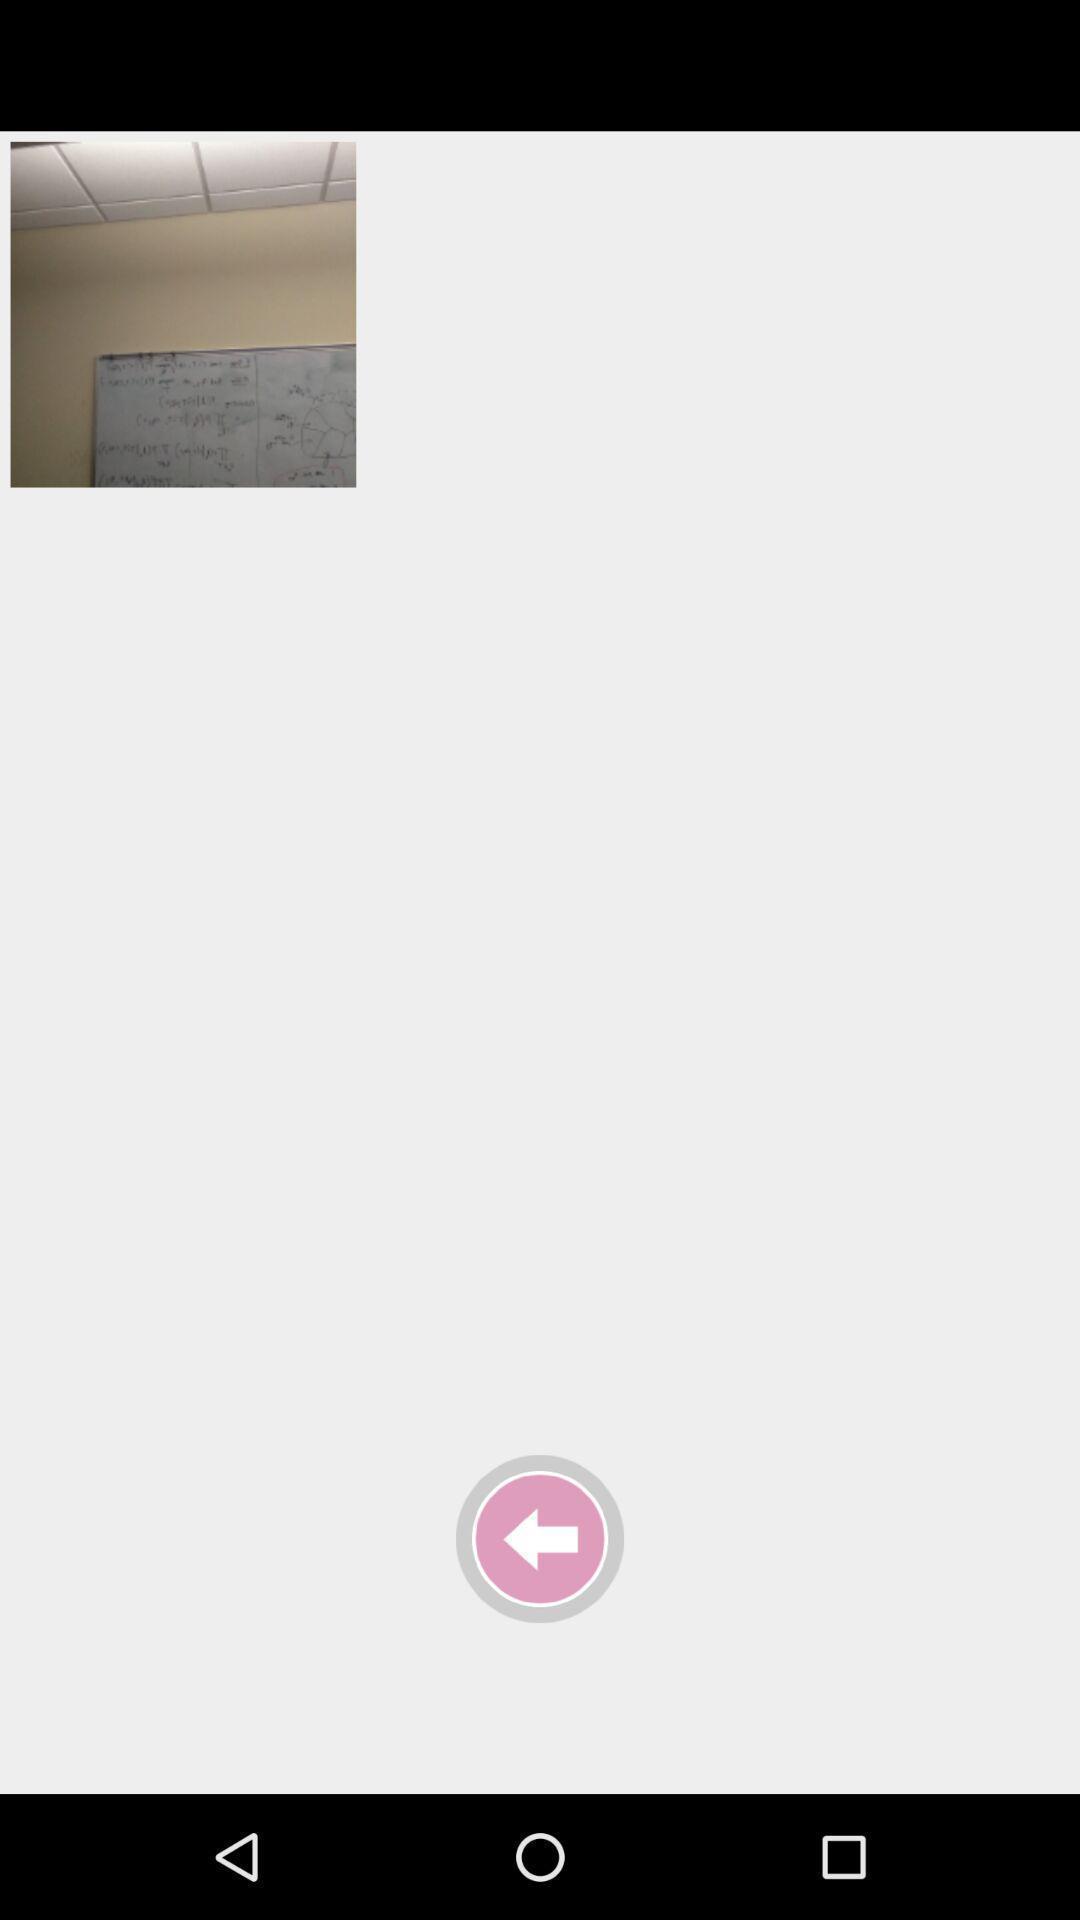Describe the content in this image. Page showing image of a blackboard in a gallery. 